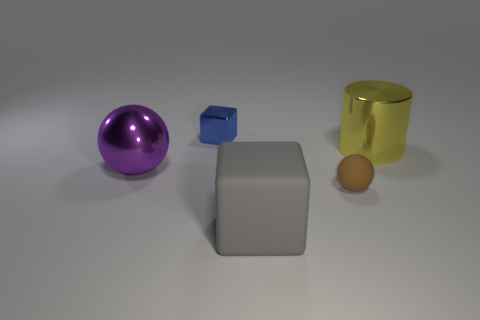There is a small object in front of the shiny sphere; is its color the same as the cylinder?
Your answer should be very brief. No. There is a metal thing that is to the right of the tiny object behind the rubber thing that is on the right side of the big gray object; what is its shape?
Provide a short and direct response. Cylinder. There is a brown ball; does it have the same size as the object that is behind the cylinder?
Offer a very short reply. Yes. Are there any gray cubes of the same size as the gray rubber object?
Provide a short and direct response. No. What number of other things are there of the same material as the large gray block
Your answer should be very brief. 1. There is a metal thing that is both in front of the tiny metal thing and on the left side of the gray cube; what is its color?
Ensure brevity in your answer.  Purple. Are the tiny object to the right of the metallic cube and the cube that is on the right side of the tiny metal cube made of the same material?
Your answer should be very brief. Yes. There is a metal object left of the blue shiny block; is its size the same as the matte ball?
Provide a succinct answer. No. Does the matte cube have the same color as the big metal object right of the big sphere?
Your answer should be very brief. No. The purple thing has what shape?
Your response must be concise. Sphere. 